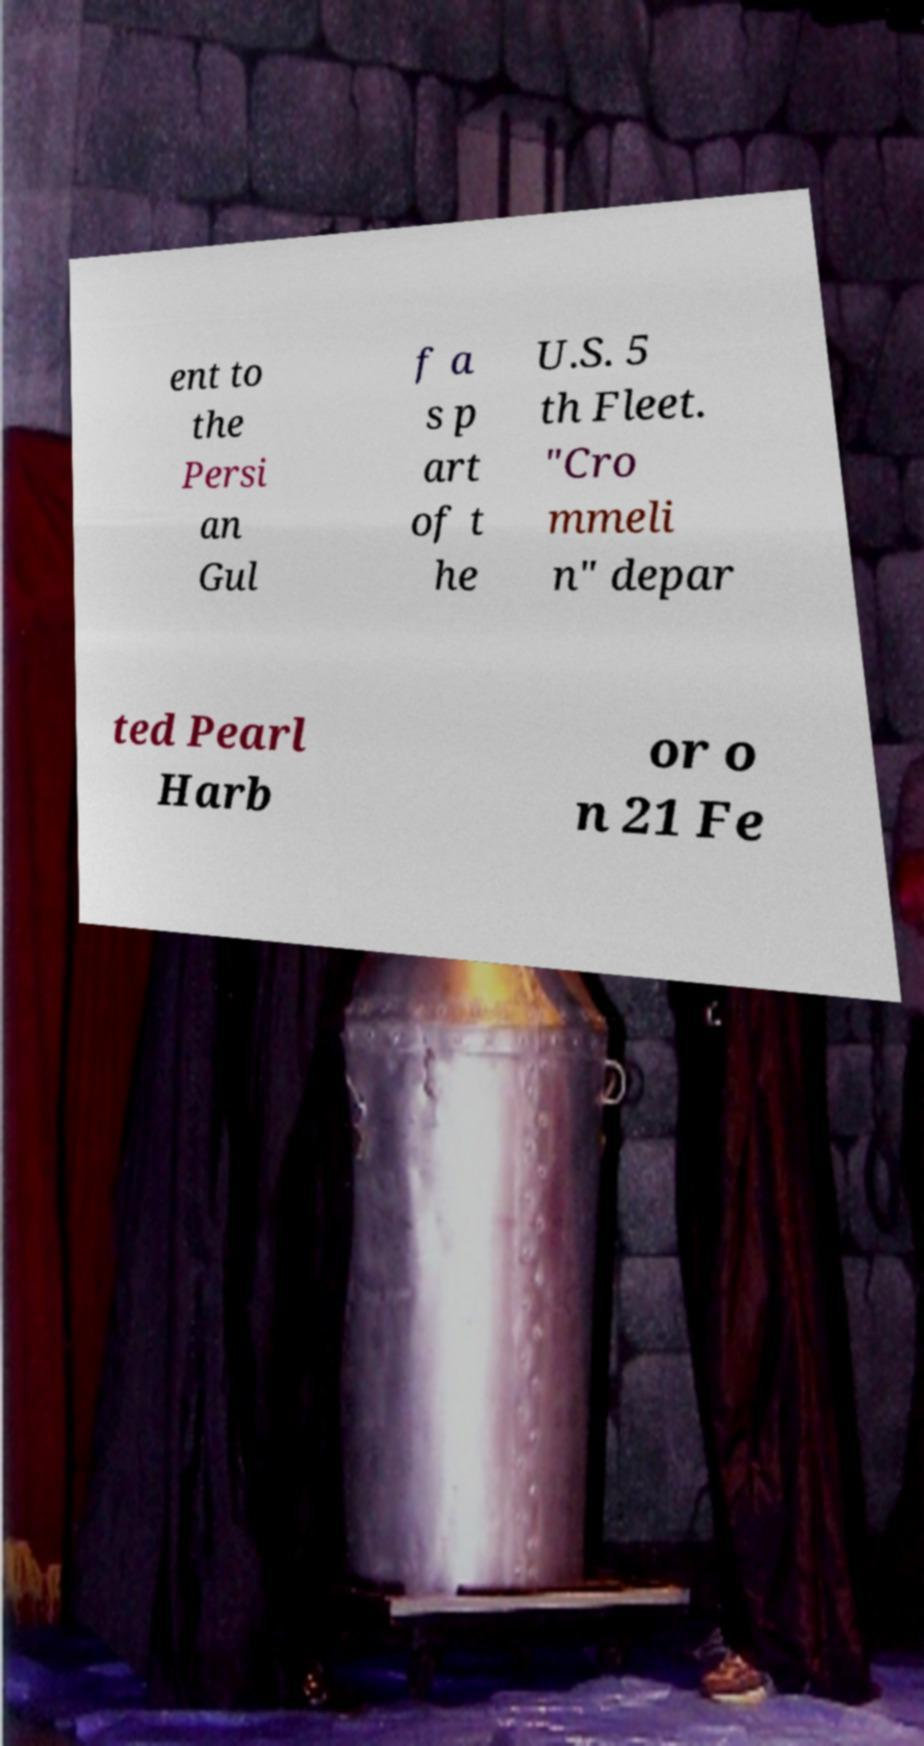There's text embedded in this image that I need extracted. Can you transcribe it verbatim? ent to the Persi an Gul f a s p art of t he U.S. 5 th Fleet. "Cro mmeli n" depar ted Pearl Harb or o n 21 Fe 